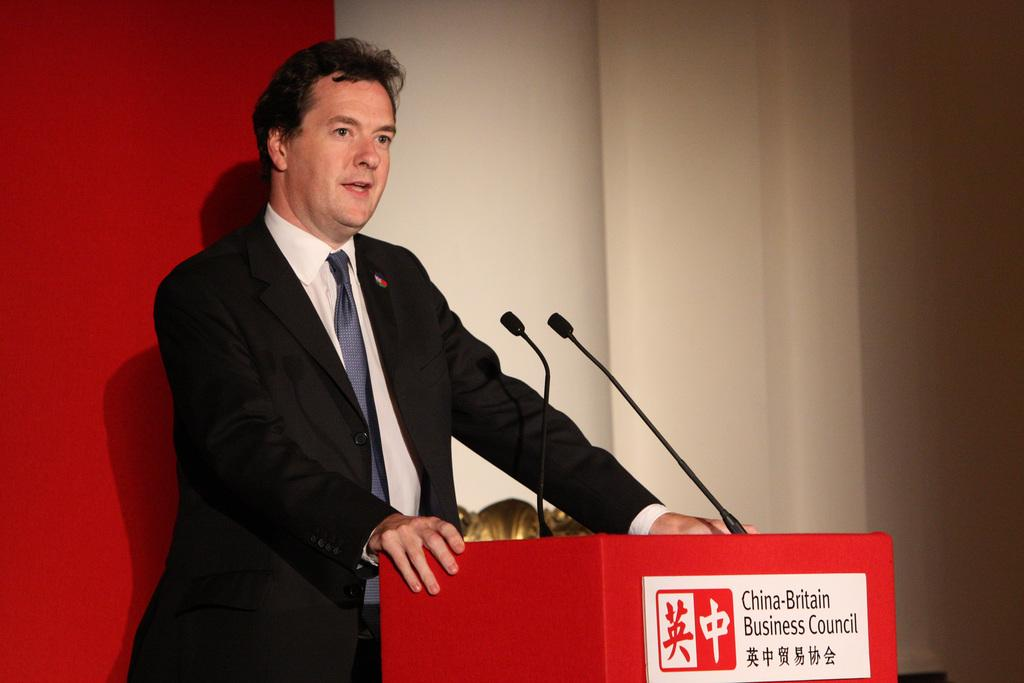Who or what is the main subject in the image? There is a person in the center of the image. What is the person doing or standing near in the image? The person is near a podium. What is the person wearing in the image? The person is wearing a suit. What can be seen in the background of the image? There is a wall in the background of the image. What type of air can be seen flowing around the person in the image? There is no airflow visible in the image; it is a still photograph. 